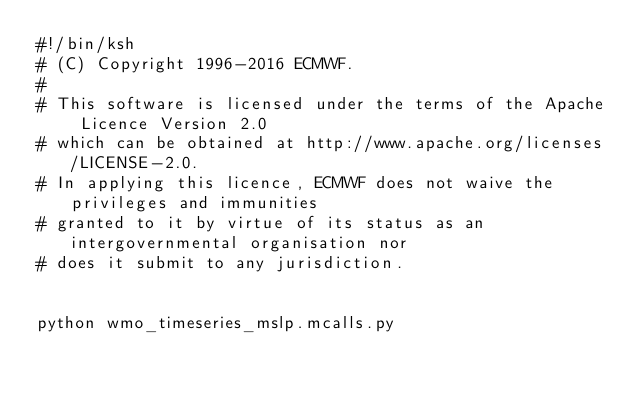<code> <loc_0><loc_0><loc_500><loc_500><_Bash_>#!/bin/ksh
# (C) Copyright 1996-2016 ECMWF.
# 
# This software is licensed under the terms of the Apache Licence Version 2.0
# which can be obtained at http://www.apache.org/licenses/LICENSE-2.0. 
# In applying this licence, ECMWF does not waive the privileges and immunities 
# granted to it by virtue of its status as an intergovernmental organisation nor
# does it submit to any jurisdiction.


python wmo_timeseries_mslp.mcalls.py
</code> 